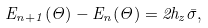<formula> <loc_0><loc_0><loc_500><loc_500>E _ { n + 1 } ( \Theta ) - E _ { n } ( \Theta ) = 2 h _ { z } \bar { \sigma } ,</formula> 